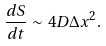<formula> <loc_0><loc_0><loc_500><loc_500>\frac { d S } { d t } \sim 4 D \Delta x ^ { 2 } .</formula> 